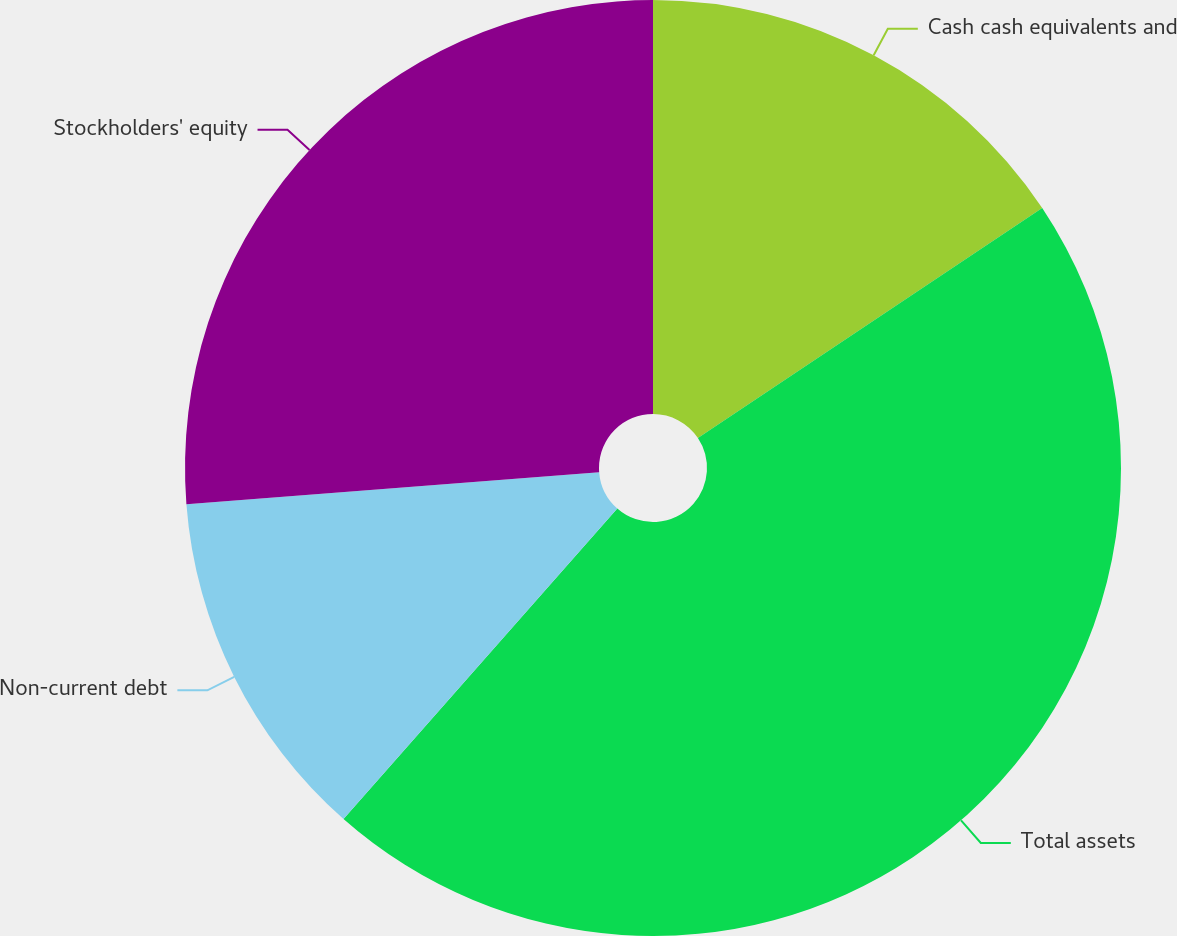Convert chart to OTSL. <chart><loc_0><loc_0><loc_500><loc_500><pie_chart><fcel>Cash cash equivalents and<fcel>Total assets<fcel>Non-current debt<fcel>Stockholders' equity<nl><fcel>15.63%<fcel>45.87%<fcel>12.27%<fcel>26.23%<nl></chart> 